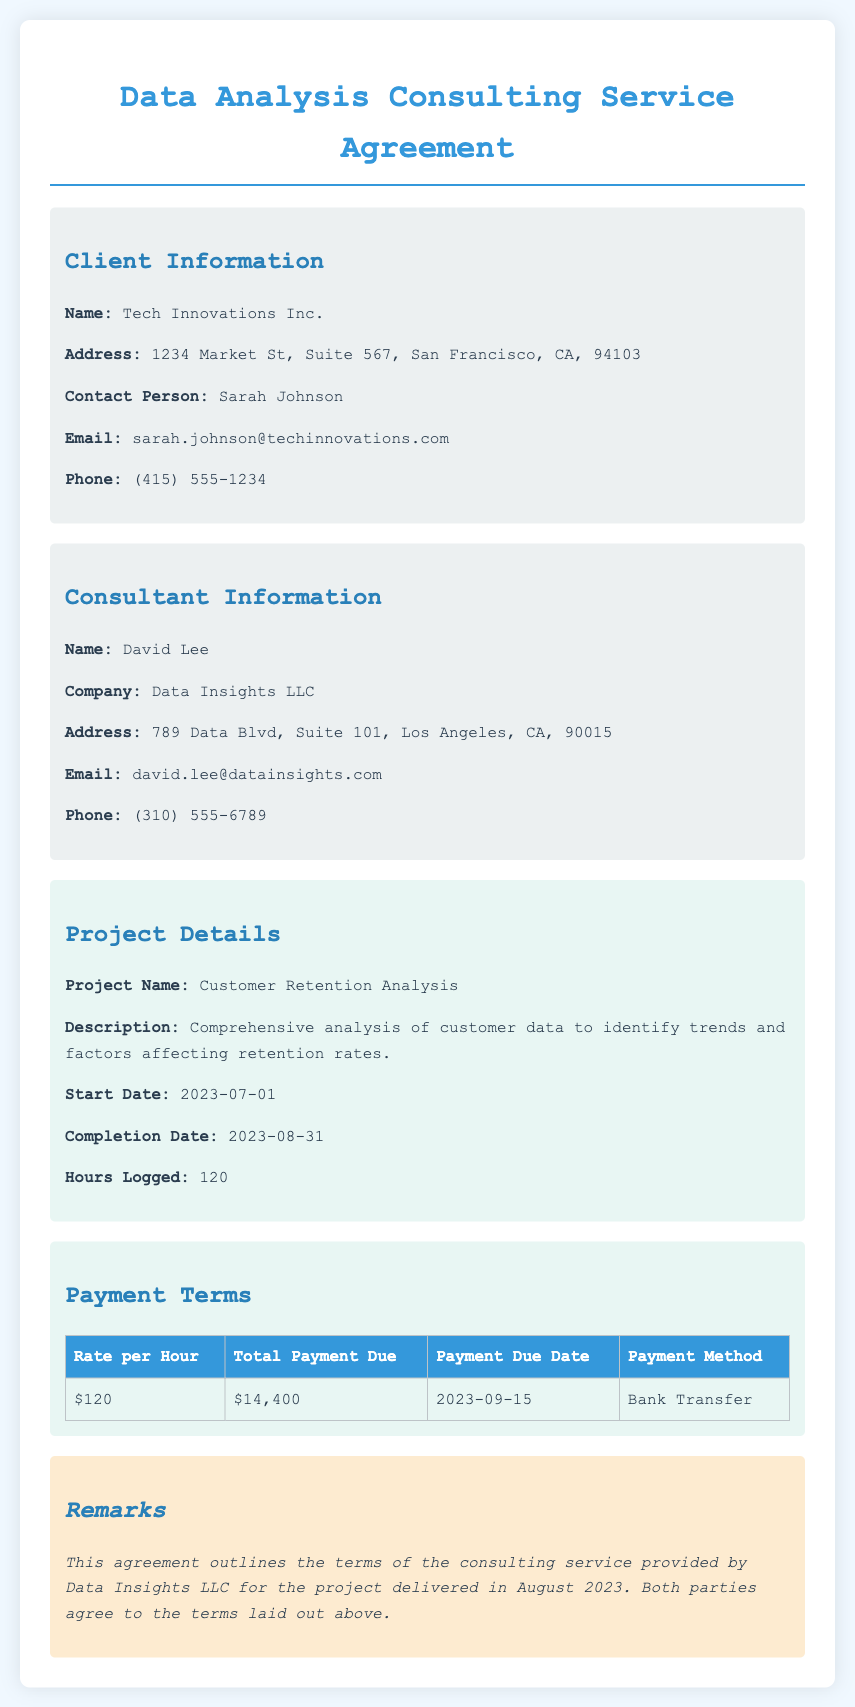what is the client's name? The client's name is listed in the document under client information.
Answer: Tech Innovations Inc what is the total payment due? The total payment due is found in the payment terms section of the document.
Answer: $14,400 what is the completion date of the project? The completion date is specified in the project details section.
Answer: 2023-08-31 how many hours were logged for the project? The hours logged is detailed in the project details section.
Answer: 120 what is the rate per hour for the consulting service? The rate per hour can be found in the payment terms table.
Answer: $120 who is the contact person for the client? The contact person is mentioned in the client information section of the document.
Answer: Sarah Johnson what is the payment method outlined in the agreement? The payment method is specified in the payment terms table.
Answer: Bank Transfer what is the start date of the project? The start date is documented in the project details section.
Answer: 2023-07-01 what is the name of the consultant? The consultant's name is provided under the consultant information section.
Answer: David Lee 